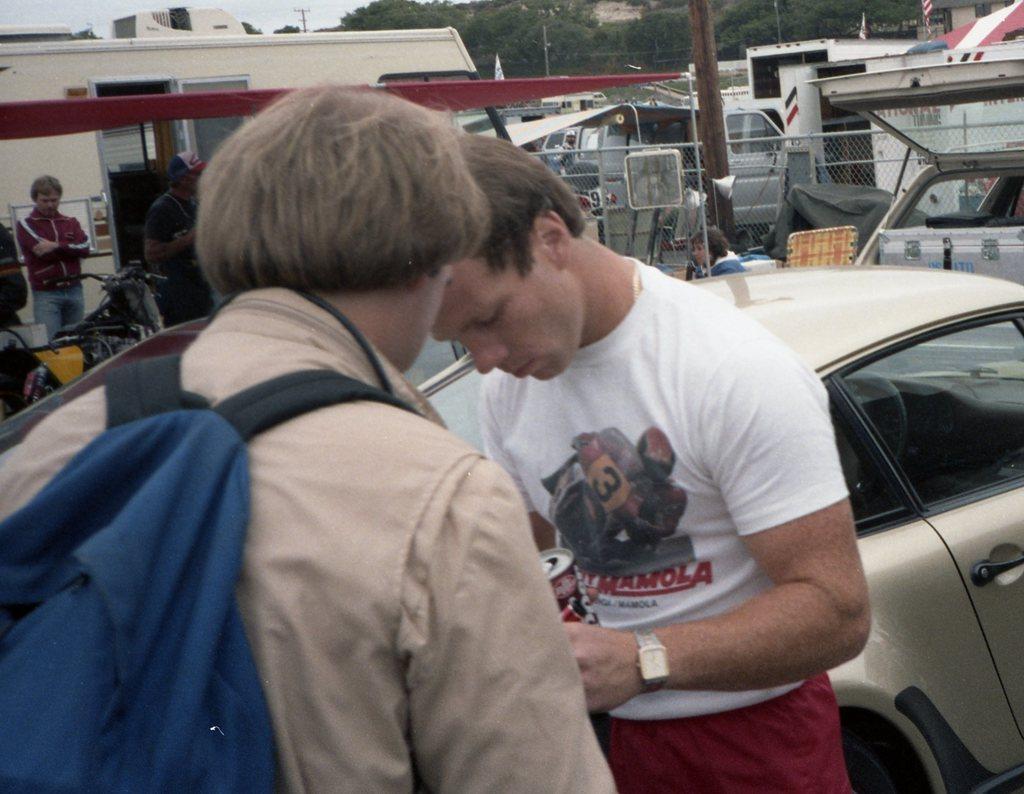Could you give a brief overview of what you see in this image? In the left side a person is standing, he wore a bag which is in blue color. In the middle another man is standing. He wore a white color t-shirt, in the right side a girl is there. 